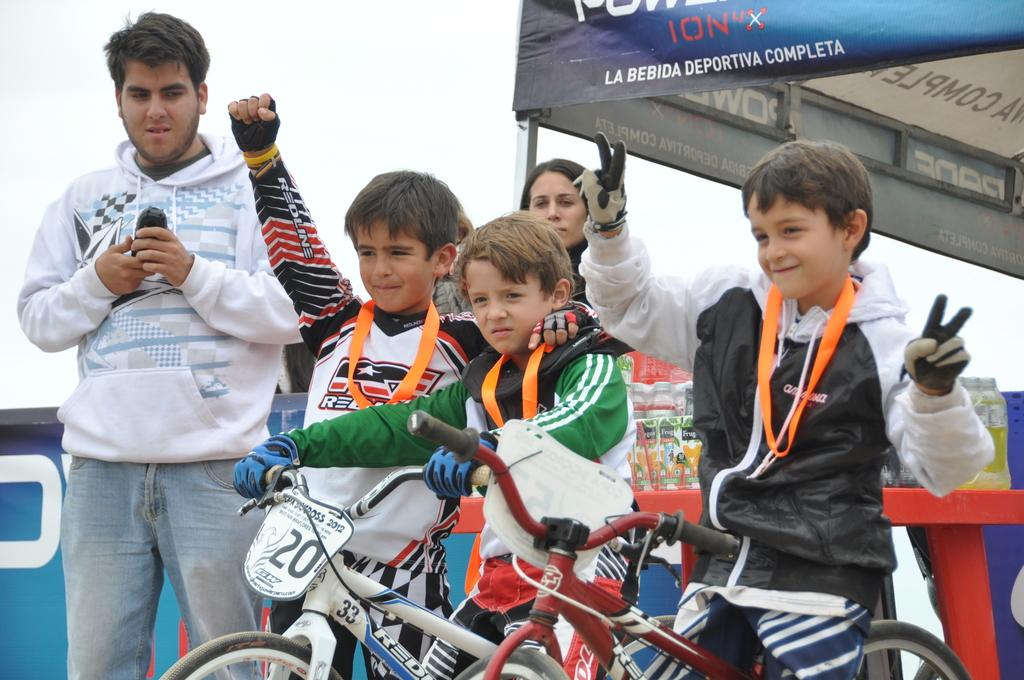How many boys are in the image? There are three boys in the image. What are the boys wearing? The boys are wearing jackets. What else can be seen on the boys in the image? The boys have medals. What are the boys doing in the image? The boys are on bicycles. Can you describe another person in the image? Yes, there is a guy wearing a white color hoodie in the image. Are there any females in the image? Yes, there is a lady in the image. What type of table can be seen in the image? There is no table present in the image. What is the chance of the boys dropping their medals while riding bicycles? It is impossible to determine the chance of the boys dropping their medals from the image alone, as it does not provide information about their actions or the environment. 